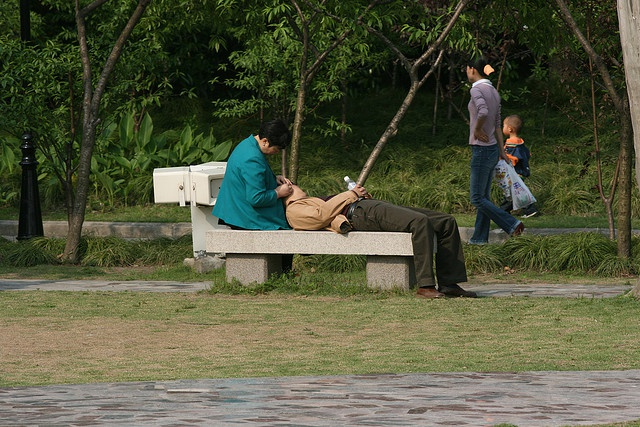Describe the objects in this image and their specific colors. I can see people in black and tan tones, bench in black, lightgray, tan, and darkgray tones, people in black and teal tones, people in black, gray, darkgreen, and darkgray tones, and people in black, brown, salmon, and maroon tones in this image. 